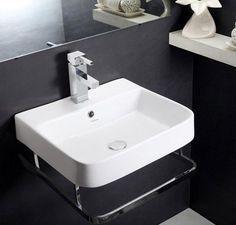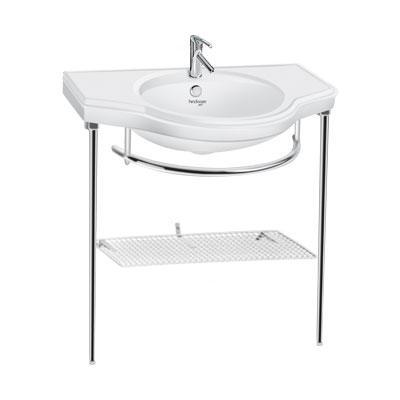The first image is the image on the left, the second image is the image on the right. Given the left and right images, does the statement "In one of the images, there is a freestanding white sink with a shelf underneath and chrome legs." hold true? Answer yes or no. Yes. The first image is the image on the left, the second image is the image on the right. Considering the images on both sides, is "There is a shelf under the sink in one of the images." valid? Answer yes or no. Yes. 